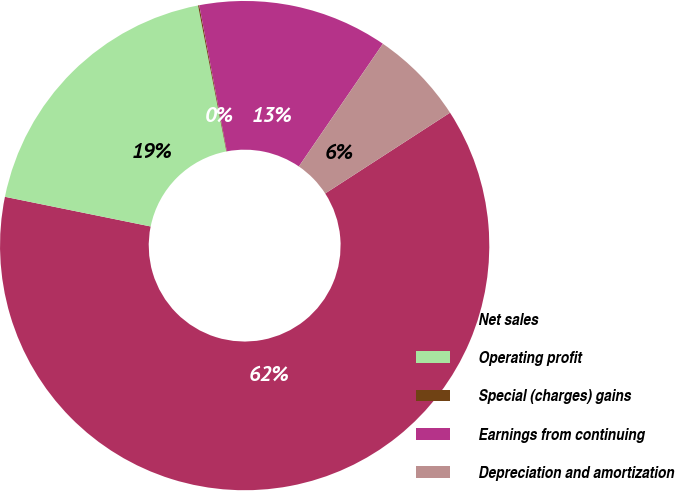Convert chart to OTSL. <chart><loc_0><loc_0><loc_500><loc_500><pie_chart><fcel>Net sales<fcel>Operating profit<fcel>Special (charges) gains<fcel>Earnings from continuing<fcel>Depreciation and amortization<nl><fcel>62.34%<fcel>18.75%<fcel>0.08%<fcel>12.53%<fcel>6.3%<nl></chart> 